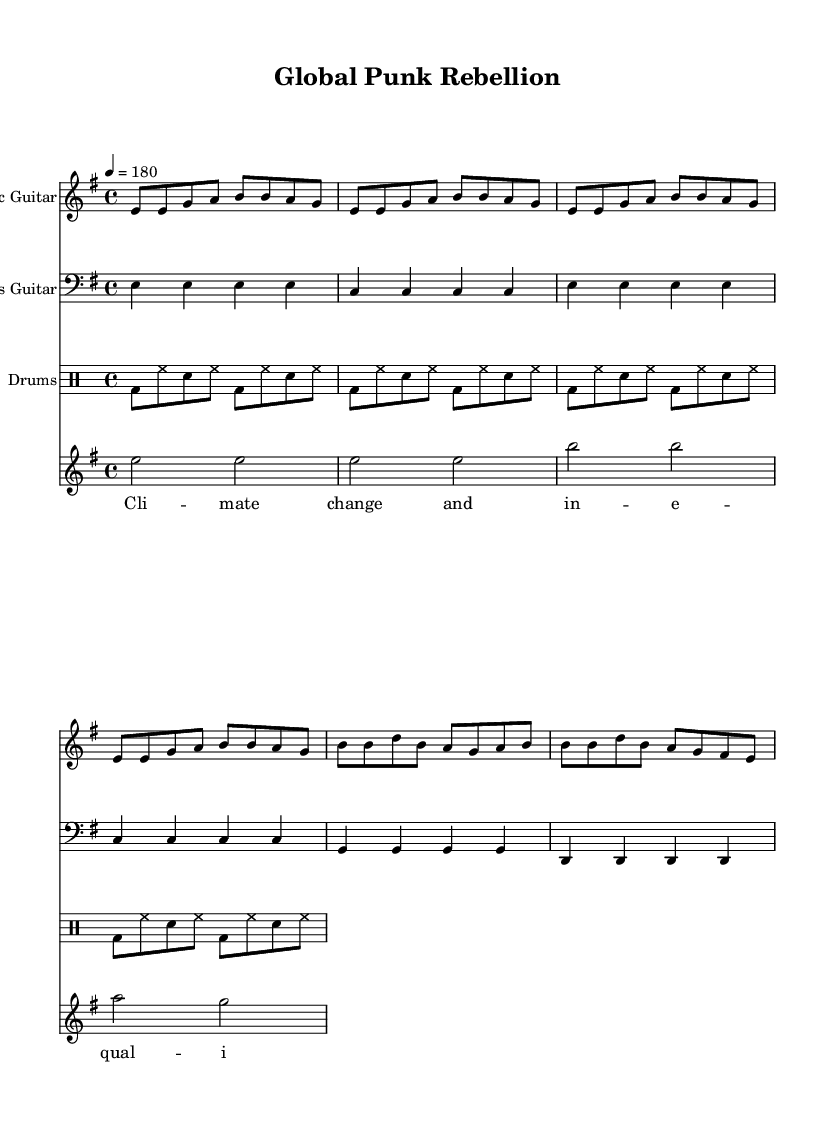What is the key signature of this music? The key signature is E minor, which includes one sharp (F#) and has a natural minor tonality. This is determined by the notation at the beginning of the score, specifically in the global variable section where "e minor" is indicated.
Answer: E minor What is the time signature of the piece? The time signature is 4/4, indicated at the beginning of the score in the global variable section. This means there are four beats in each measure and a quarter note receives one beat.
Answer: 4/4 What is the tempo marking for the score? The tempo marking is 180 beats per minute, indicated as "4 = 180" in the global variable section. This specifies the speed at which the music should be played, with the quarter note getting the beat.
Answer: 180 How many measures are in the chorus section? The chorus section contains four measures. This can be counted by looking at the breakdown of the music for the chorus section specifically written under the electric guitar part, which lists the corresponding notes over four measures.
Answer: 4 Which instrument has the highest musical range in this score? The electric guitar generally has the highest pitch range, as it plays melody lines that typically reach higher notes compared to the bass guitar and drums, which have lower-ranging parts. This can be inferred by analyzing the note pitches indicated in the different parts, where the electric guitar starts at E and goes to B.
Answer: Electric Guitar What social issue is symbolically represented through the lyrics? The lyrics focus on climate change and inequality, as indicated by the phrases "climate change" and "inequality" that are explicitly stated in the vocal section of the score, representing current global issues.
Answer: Climate change and inequality What type of beat is primarily used in the drum part? The beat used in the drum part is a basic punk beat, characterized by a steady bass drum and snare combination that is common in punk rock music. This can be concluded from the drummode section which shows repeating patterns typical of punk rhythms.
Answer: Basic punk beat 